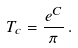Convert formula to latex. <formula><loc_0><loc_0><loc_500><loc_500>T _ { c } = \frac { e ^ { C } } { \pi } \, .</formula> 